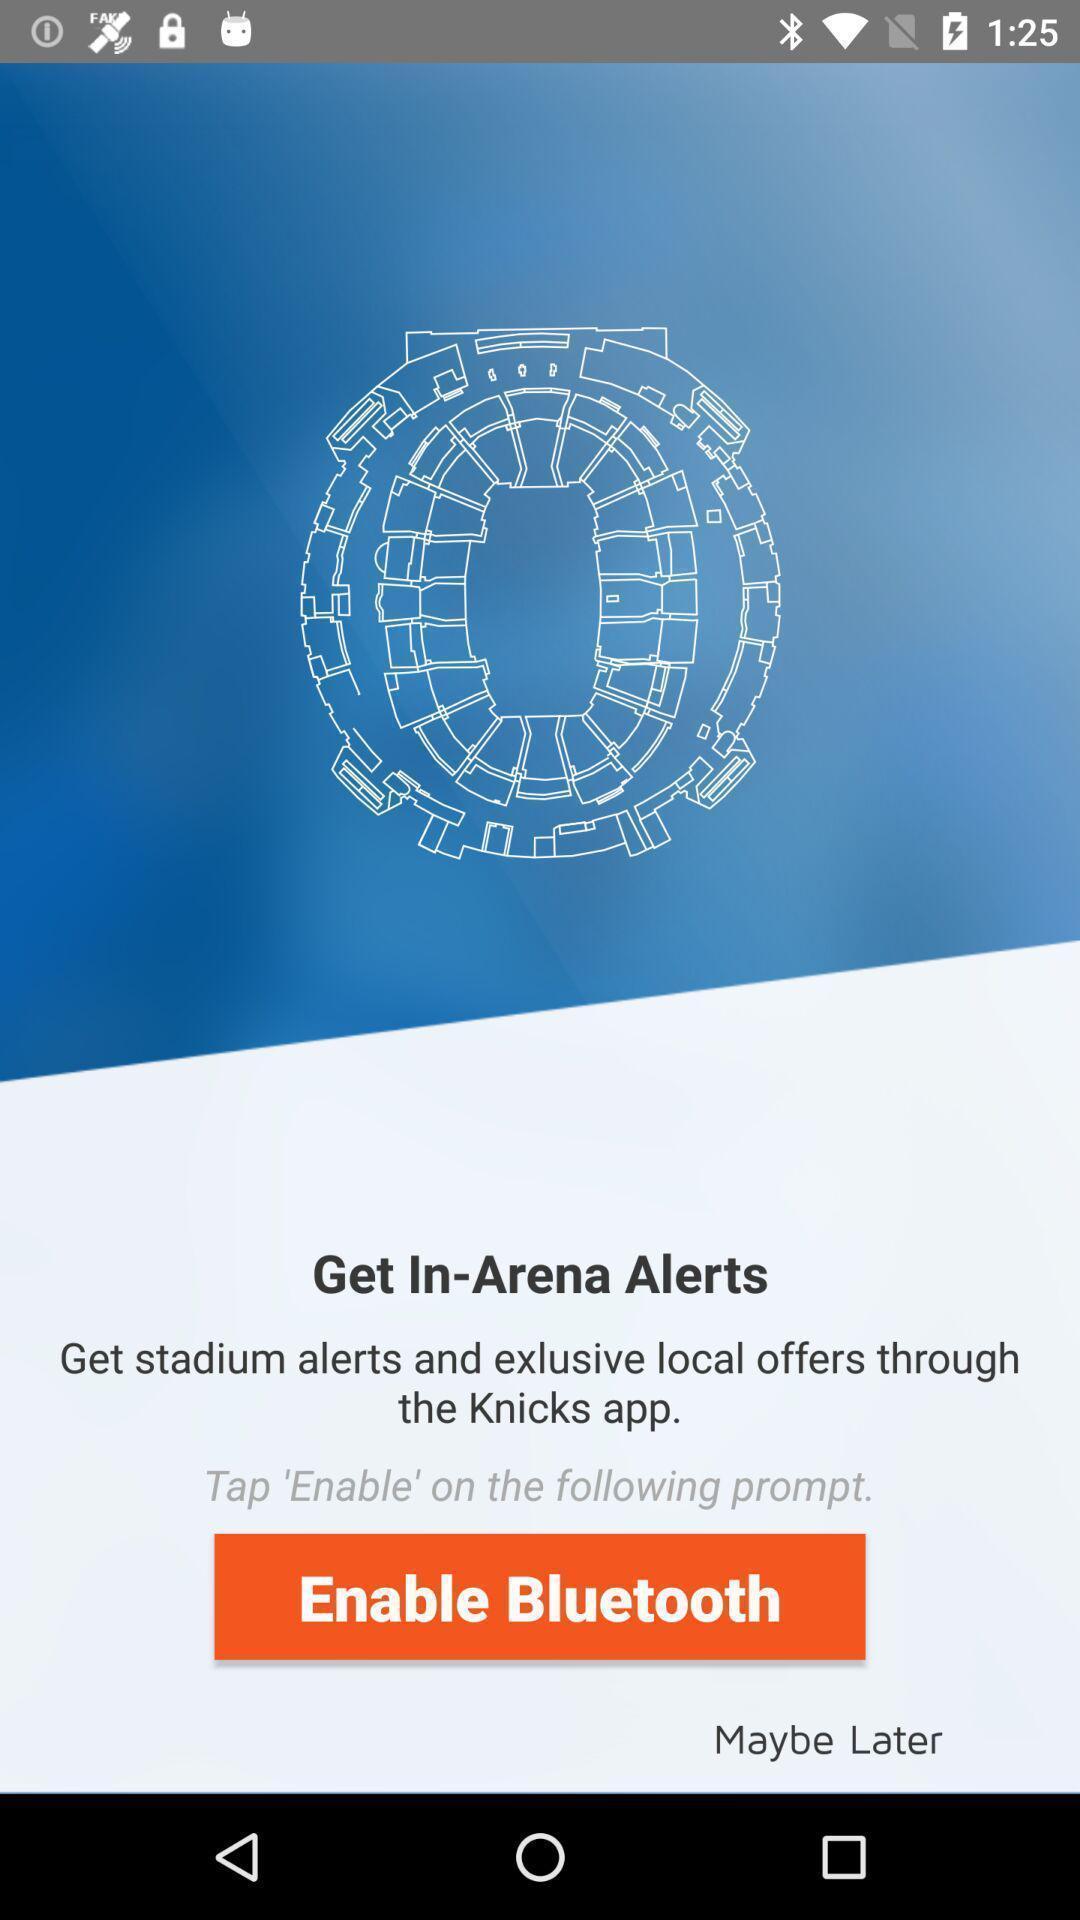Describe the visual elements of this screenshot. Welcome page. 